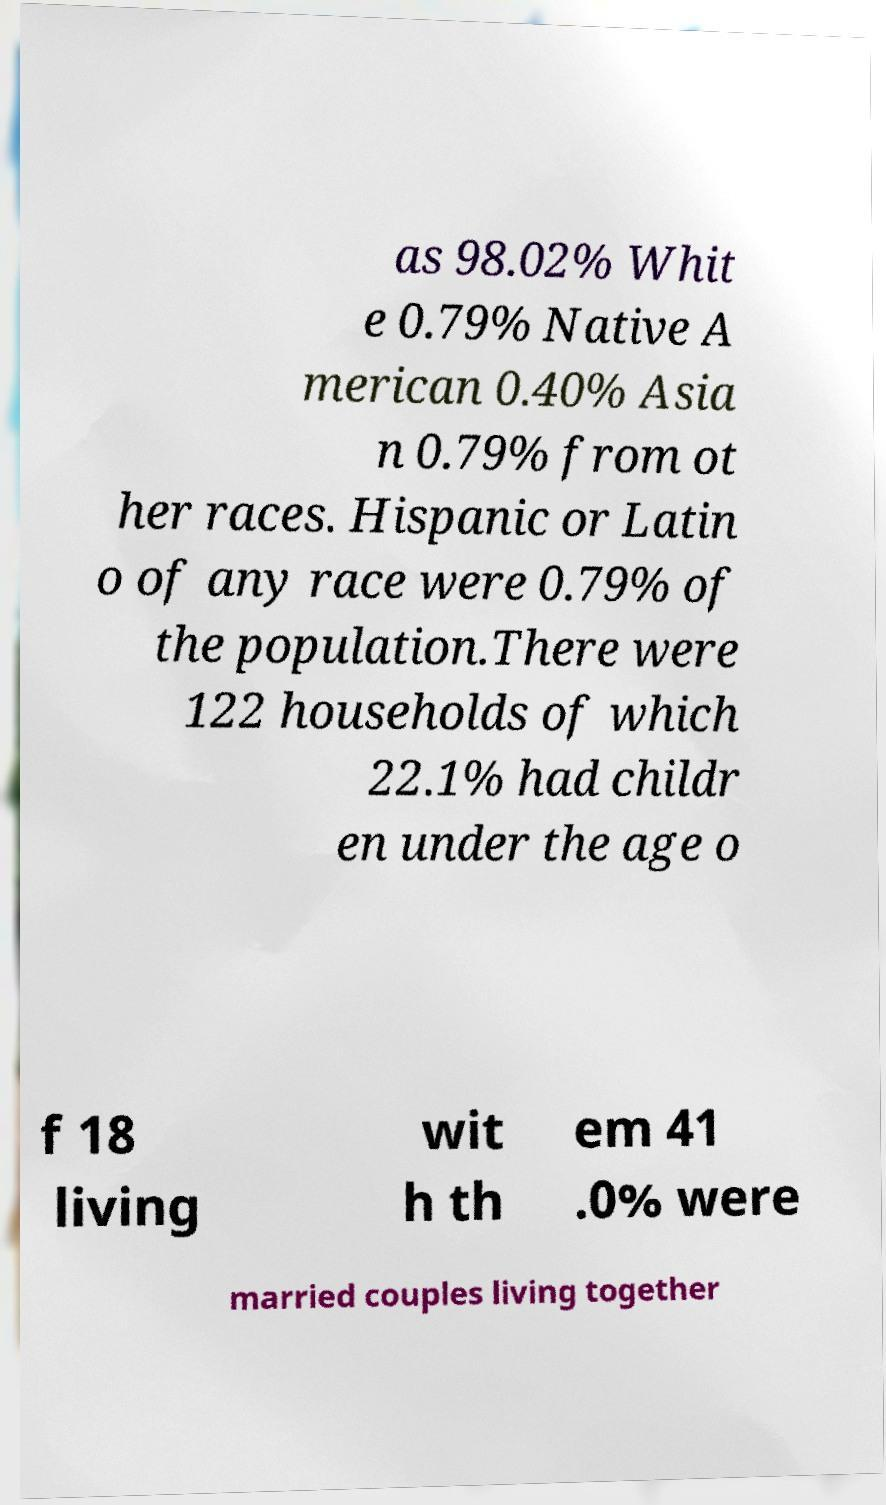What messages or text are displayed in this image? I need them in a readable, typed format. as 98.02% Whit e 0.79% Native A merican 0.40% Asia n 0.79% from ot her races. Hispanic or Latin o of any race were 0.79% of the population.There were 122 households of which 22.1% had childr en under the age o f 18 living wit h th em 41 .0% were married couples living together 